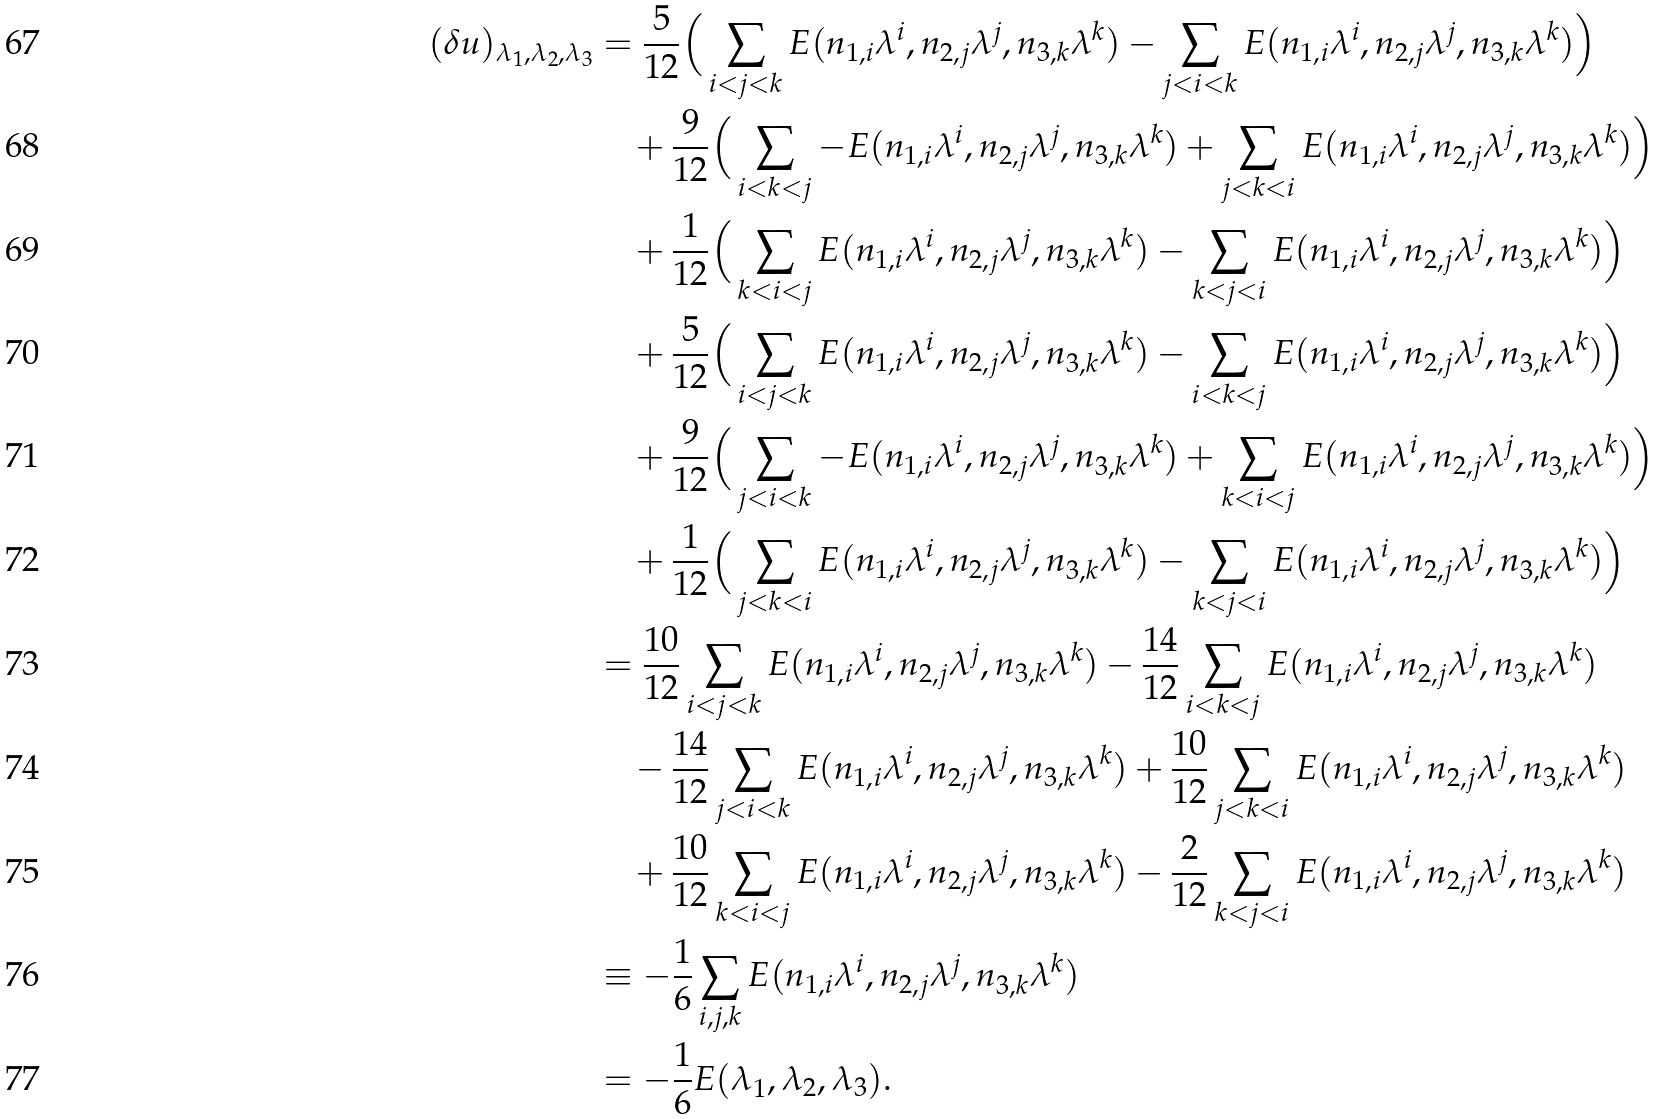<formula> <loc_0><loc_0><loc_500><loc_500>( \delta u ) _ { \lambda _ { 1 } , \lambda _ { 2 } , \lambda _ { 3 } } & = \frac { 5 } { 1 2 } \Big { ( } \sum _ { i < j < k } E ( n _ { 1 , i } \lambda ^ { i } , n _ { 2 , j } \lambda ^ { j } , n _ { 3 , k } \lambda ^ { k } ) - \sum _ { j < i < k } E ( n _ { 1 , i } \lambda ^ { i } , n _ { 2 , j } \lambda ^ { j } , n _ { 3 , k } \lambda ^ { k } ) \Big { ) } \\ & \quad + \frac { 9 } { 1 2 } \Big { ( } \sum _ { i < k < j } - E ( n _ { 1 , i } \lambda ^ { i } , n _ { 2 , j } \lambda ^ { j } , n _ { 3 , k } \lambda ^ { k } ) + \sum _ { j < k < i } E ( n _ { 1 , i } \lambda ^ { i } , n _ { 2 , j } \lambda ^ { j } , n _ { 3 , k } \lambda ^ { k } ) \Big { ) } \\ & \quad + \frac { 1 } { 1 2 } \Big { ( } \sum _ { k < i < j } E ( n _ { 1 , i } \lambda ^ { i } , n _ { 2 , j } \lambda ^ { j } , n _ { 3 , k } \lambda ^ { k } ) - \sum _ { k < j < i } E ( n _ { 1 , i } \lambda ^ { i } , n _ { 2 , j } \lambda ^ { j } , n _ { 3 , k } \lambda ^ { k } ) \Big { ) } \\ & \quad + \frac { 5 } { 1 2 } \Big { ( } \sum _ { i < j < k } E ( n _ { 1 , i } \lambda ^ { i } , n _ { 2 , j } \lambda ^ { j } , n _ { 3 , k } \lambda ^ { k } ) - \sum _ { i < k < j } E ( n _ { 1 , i } \lambda ^ { i } , n _ { 2 , j } \lambda ^ { j } , n _ { 3 , k } \lambda ^ { k } ) \Big { ) } \\ & \quad + \frac { 9 } { 1 2 } \Big { ( } \sum _ { j < i < k } - E ( n _ { 1 , i } \lambda ^ { i } , n _ { 2 , j } \lambda ^ { j } , n _ { 3 , k } \lambda ^ { k } ) + \sum _ { k < i < j } E ( n _ { 1 , i } \lambda ^ { i } , n _ { 2 , j } \lambda ^ { j } , n _ { 3 , k } \lambda ^ { k } ) \Big { ) } \\ & \quad + \frac { 1 } { 1 2 } \Big { ( } \sum _ { j < k < i } E ( n _ { 1 , i } \lambda ^ { i } , n _ { 2 , j } \lambda ^ { j } , n _ { 3 , k } \lambda ^ { k } ) - \sum _ { k < j < i } E ( n _ { 1 , i } \lambda ^ { i } , n _ { 2 , j } \lambda ^ { j } , n _ { 3 , k } \lambda ^ { k } ) \Big { ) } \\ & = \frac { 1 0 } { 1 2 } \sum _ { i < j < k } E ( n _ { 1 , i } \lambda ^ { i } , n _ { 2 , j } \lambda ^ { j } , n _ { 3 , k } \lambda ^ { k } ) - \frac { 1 4 } { 1 2 } \sum _ { i < k < j } E ( n _ { 1 , i } \lambda ^ { i } , n _ { 2 , j } \lambda ^ { j } , n _ { 3 , k } \lambda ^ { k } ) \\ & \quad - \frac { 1 4 } { 1 2 } \sum _ { j < i < k } E ( n _ { 1 , i } \lambda ^ { i } , n _ { 2 , j } \lambda ^ { j } , n _ { 3 , k } \lambda ^ { k } ) + \frac { 1 0 } { 1 2 } \sum _ { j < k < i } E ( n _ { 1 , i } \lambda ^ { i } , n _ { 2 , j } \lambda ^ { j } , n _ { 3 , k } \lambda ^ { k } ) \\ & \quad + \frac { 1 0 } { 1 2 } \sum _ { k < i < j } E ( n _ { 1 , i } \lambda ^ { i } , n _ { 2 , j } \lambda ^ { j } , n _ { 3 , k } \lambda ^ { k } ) - \frac { 2 } { 1 2 } \sum _ { k < j < i } E ( n _ { 1 , i } \lambda ^ { i } , n _ { 2 , j } \lambda ^ { j } , n _ { 3 , k } \lambda ^ { k } ) \\ & \equiv - \frac { 1 } { 6 } \sum _ { i , j , k } E ( n _ { 1 , i } \lambda ^ { i } , n _ { 2 , j } \lambda ^ { j } , n _ { 3 , k } \lambda ^ { k } ) \\ & = - \frac { 1 } { 6 } E ( \lambda _ { 1 } , \lambda _ { 2 } , \lambda _ { 3 } ) .</formula> 